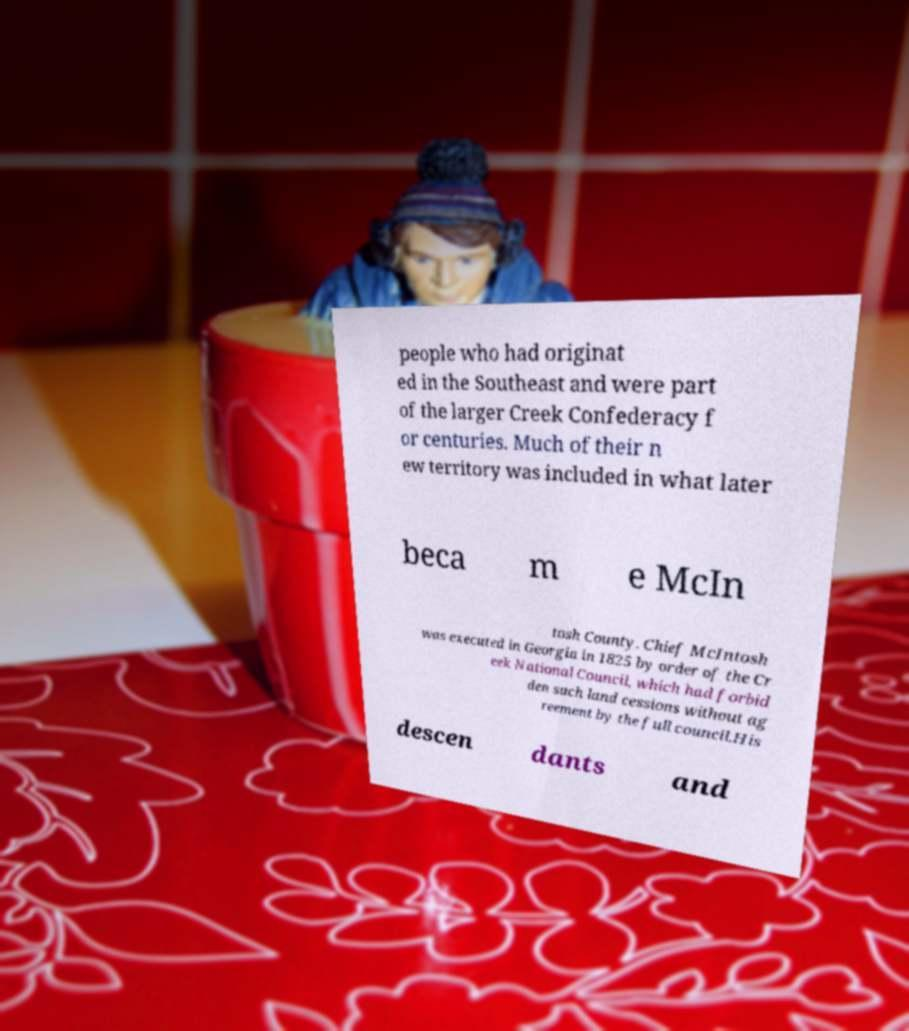I need the written content from this picture converted into text. Can you do that? people who had originat ed in the Southeast and were part of the larger Creek Confederacy f or centuries. Much of their n ew territory was included in what later beca m e McIn tosh County. Chief McIntosh was executed in Georgia in 1825 by order of the Cr eek National Council, which had forbid den such land cessions without ag reement by the full council.His descen dants and 